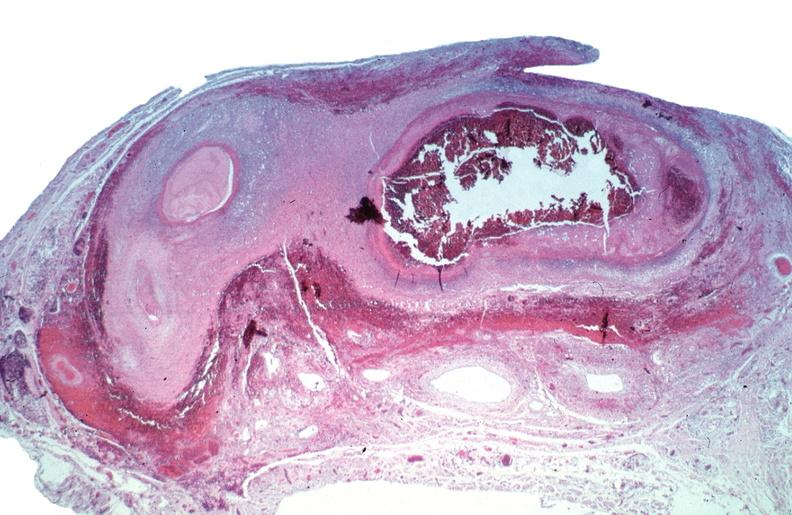what does this image show?
Answer the question using a single word or phrase. Vasculitis 